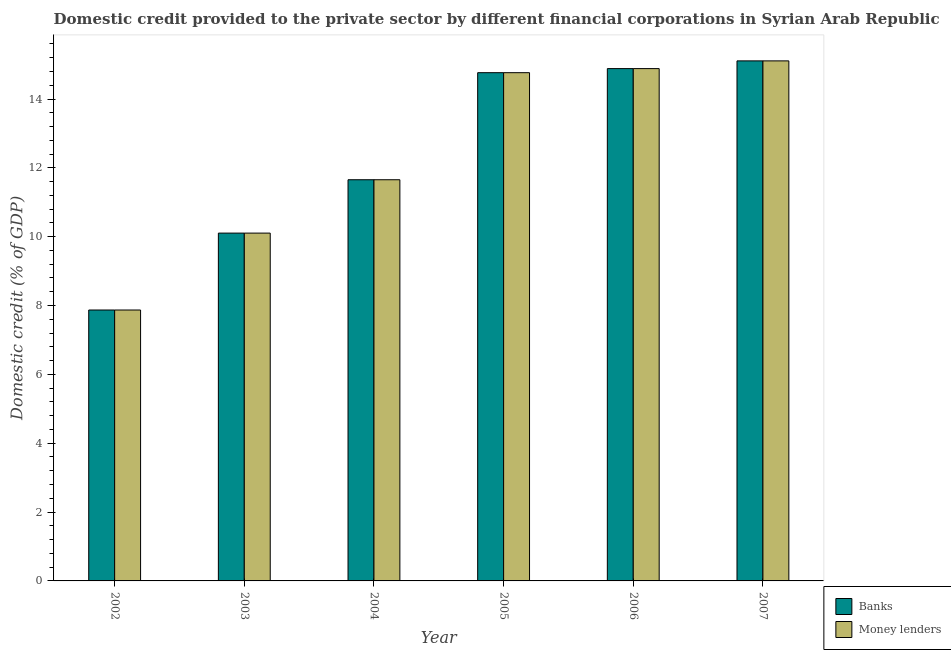Are the number of bars on each tick of the X-axis equal?
Offer a terse response. Yes. What is the label of the 6th group of bars from the left?
Provide a short and direct response. 2007. In how many cases, is the number of bars for a given year not equal to the number of legend labels?
Provide a short and direct response. 0. What is the domestic credit provided by money lenders in 2005?
Ensure brevity in your answer.  14.76. Across all years, what is the maximum domestic credit provided by money lenders?
Your response must be concise. 15.11. Across all years, what is the minimum domestic credit provided by banks?
Your answer should be compact. 7.87. In which year was the domestic credit provided by banks maximum?
Make the answer very short. 2007. What is the total domestic credit provided by money lenders in the graph?
Your answer should be very brief. 74.38. What is the difference between the domestic credit provided by money lenders in 2003 and that in 2006?
Your answer should be compact. -4.78. What is the difference between the domestic credit provided by money lenders in 2007 and the domestic credit provided by banks in 2004?
Give a very brief answer. 3.45. What is the average domestic credit provided by money lenders per year?
Provide a short and direct response. 12.4. In how many years, is the domestic credit provided by banks greater than 8.4 %?
Provide a short and direct response. 5. What is the ratio of the domestic credit provided by banks in 2003 to that in 2007?
Make the answer very short. 0.67. Is the domestic credit provided by money lenders in 2002 less than that in 2003?
Provide a short and direct response. Yes. What is the difference between the highest and the second highest domestic credit provided by banks?
Ensure brevity in your answer.  0.22. What is the difference between the highest and the lowest domestic credit provided by money lenders?
Keep it short and to the point. 7.24. In how many years, is the domestic credit provided by banks greater than the average domestic credit provided by banks taken over all years?
Your response must be concise. 3. What does the 2nd bar from the left in 2003 represents?
Keep it short and to the point. Money lenders. What does the 1st bar from the right in 2006 represents?
Your response must be concise. Money lenders. How many years are there in the graph?
Make the answer very short. 6. Are the values on the major ticks of Y-axis written in scientific E-notation?
Keep it short and to the point. No. Does the graph contain grids?
Ensure brevity in your answer.  No. How many legend labels are there?
Provide a succinct answer. 2. How are the legend labels stacked?
Your answer should be very brief. Vertical. What is the title of the graph?
Offer a terse response. Domestic credit provided to the private sector by different financial corporations in Syrian Arab Republic. Does "Canada" appear as one of the legend labels in the graph?
Give a very brief answer. No. What is the label or title of the Y-axis?
Provide a short and direct response. Domestic credit (% of GDP). What is the Domestic credit (% of GDP) of Banks in 2002?
Your answer should be very brief. 7.87. What is the Domestic credit (% of GDP) of Money lenders in 2002?
Provide a short and direct response. 7.87. What is the Domestic credit (% of GDP) of Banks in 2003?
Offer a very short reply. 10.1. What is the Domestic credit (% of GDP) in Money lenders in 2003?
Offer a terse response. 10.1. What is the Domestic credit (% of GDP) of Banks in 2004?
Provide a succinct answer. 11.65. What is the Domestic credit (% of GDP) in Money lenders in 2004?
Provide a succinct answer. 11.65. What is the Domestic credit (% of GDP) in Banks in 2005?
Your answer should be compact. 14.76. What is the Domestic credit (% of GDP) in Money lenders in 2005?
Make the answer very short. 14.76. What is the Domestic credit (% of GDP) of Banks in 2006?
Provide a succinct answer. 14.88. What is the Domestic credit (% of GDP) in Money lenders in 2006?
Offer a very short reply. 14.88. What is the Domestic credit (% of GDP) of Banks in 2007?
Your response must be concise. 15.11. What is the Domestic credit (% of GDP) of Money lenders in 2007?
Provide a short and direct response. 15.11. Across all years, what is the maximum Domestic credit (% of GDP) in Banks?
Provide a short and direct response. 15.11. Across all years, what is the maximum Domestic credit (% of GDP) of Money lenders?
Offer a very short reply. 15.11. Across all years, what is the minimum Domestic credit (% of GDP) in Banks?
Provide a short and direct response. 7.87. Across all years, what is the minimum Domestic credit (% of GDP) of Money lenders?
Make the answer very short. 7.87. What is the total Domestic credit (% of GDP) of Banks in the graph?
Your answer should be very brief. 74.38. What is the total Domestic credit (% of GDP) in Money lenders in the graph?
Ensure brevity in your answer.  74.38. What is the difference between the Domestic credit (% of GDP) of Banks in 2002 and that in 2003?
Ensure brevity in your answer.  -2.23. What is the difference between the Domestic credit (% of GDP) in Money lenders in 2002 and that in 2003?
Make the answer very short. -2.23. What is the difference between the Domestic credit (% of GDP) of Banks in 2002 and that in 2004?
Offer a terse response. -3.78. What is the difference between the Domestic credit (% of GDP) of Money lenders in 2002 and that in 2004?
Offer a very short reply. -3.78. What is the difference between the Domestic credit (% of GDP) in Banks in 2002 and that in 2005?
Make the answer very short. -6.89. What is the difference between the Domestic credit (% of GDP) of Money lenders in 2002 and that in 2005?
Your answer should be compact. -6.89. What is the difference between the Domestic credit (% of GDP) in Banks in 2002 and that in 2006?
Offer a terse response. -7.01. What is the difference between the Domestic credit (% of GDP) in Money lenders in 2002 and that in 2006?
Offer a very short reply. -7.01. What is the difference between the Domestic credit (% of GDP) in Banks in 2002 and that in 2007?
Provide a short and direct response. -7.24. What is the difference between the Domestic credit (% of GDP) of Money lenders in 2002 and that in 2007?
Ensure brevity in your answer.  -7.24. What is the difference between the Domestic credit (% of GDP) in Banks in 2003 and that in 2004?
Offer a terse response. -1.55. What is the difference between the Domestic credit (% of GDP) in Money lenders in 2003 and that in 2004?
Keep it short and to the point. -1.55. What is the difference between the Domestic credit (% of GDP) of Banks in 2003 and that in 2005?
Your answer should be compact. -4.66. What is the difference between the Domestic credit (% of GDP) of Money lenders in 2003 and that in 2005?
Give a very brief answer. -4.66. What is the difference between the Domestic credit (% of GDP) in Banks in 2003 and that in 2006?
Provide a succinct answer. -4.78. What is the difference between the Domestic credit (% of GDP) in Money lenders in 2003 and that in 2006?
Provide a short and direct response. -4.78. What is the difference between the Domestic credit (% of GDP) in Banks in 2003 and that in 2007?
Make the answer very short. -5. What is the difference between the Domestic credit (% of GDP) in Money lenders in 2003 and that in 2007?
Provide a short and direct response. -5. What is the difference between the Domestic credit (% of GDP) in Banks in 2004 and that in 2005?
Provide a short and direct response. -3.11. What is the difference between the Domestic credit (% of GDP) of Money lenders in 2004 and that in 2005?
Offer a very short reply. -3.11. What is the difference between the Domestic credit (% of GDP) in Banks in 2004 and that in 2006?
Offer a very short reply. -3.23. What is the difference between the Domestic credit (% of GDP) in Money lenders in 2004 and that in 2006?
Your answer should be very brief. -3.23. What is the difference between the Domestic credit (% of GDP) of Banks in 2004 and that in 2007?
Ensure brevity in your answer.  -3.45. What is the difference between the Domestic credit (% of GDP) of Money lenders in 2004 and that in 2007?
Your response must be concise. -3.45. What is the difference between the Domestic credit (% of GDP) of Banks in 2005 and that in 2006?
Make the answer very short. -0.12. What is the difference between the Domestic credit (% of GDP) in Money lenders in 2005 and that in 2006?
Your answer should be compact. -0.12. What is the difference between the Domestic credit (% of GDP) of Banks in 2005 and that in 2007?
Your answer should be very brief. -0.34. What is the difference between the Domestic credit (% of GDP) in Money lenders in 2005 and that in 2007?
Offer a very short reply. -0.34. What is the difference between the Domestic credit (% of GDP) in Banks in 2006 and that in 2007?
Offer a terse response. -0.22. What is the difference between the Domestic credit (% of GDP) in Money lenders in 2006 and that in 2007?
Ensure brevity in your answer.  -0.22. What is the difference between the Domestic credit (% of GDP) in Banks in 2002 and the Domestic credit (% of GDP) in Money lenders in 2003?
Your answer should be compact. -2.23. What is the difference between the Domestic credit (% of GDP) in Banks in 2002 and the Domestic credit (% of GDP) in Money lenders in 2004?
Offer a very short reply. -3.78. What is the difference between the Domestic credit (% of GDP) in Banks in 2002 and the Domestic credit (% of GDP) in Money lenders in 2005?
Your answer should be very brief. -6.89. What is the difference between the Domestic credit (% of GDP) of Banks in 2002 and the Domestic credit (% of GDP) of Money lenders in 2006?
Provide a short and direct response. -7.01. What is the difference between the Domestic credit (% of GDP) of Banks in 2002 and the Domestic credit (% of GDP) of Money lenders in 2007?
Your answer should be very brief. -7.24. What is the difference between the Domestic credit (% of GDP) in Banks in 2003 and the Domestic credit (% of GDP) in Money lenders in 2004?
Your answer should be very brief. -1.55. What is the difference between the Domestic credit (% of GDP) in Banks in 2003 and the Domestic credit (% of GDP) in Money lenders in 2005?
Make the answer very short. -4.66. What is the difference between the Domestic credit (% of GDP) of Banks in 2003 and the Domestic credit (% of GDP) of Money lenders in 2006?
Offer a very short reply. -4.78. What is the difference between the Domestic credit (% of GDP) of Banks in 2003 and the Domestic credit (% of GDP) of Money lenders in 2007?
Offer a very short reply. -5. What is the difference between the Domestic credit (% of GDP) in Banks in 2004 and the Domestic credit (% of GDP) in Money lenders in 2005?
Offer a very short reply. -3.11. What is the difference between the Domestic credit (% of GDP) of Banks in 2004 and the Domestic credit (% of GDP) of Money lenders in 2006?
Ensure brevity in your answer.  -3.23. What is the difference between the Domestic credit (% of GDP) of Banks in 2004 and the Domestic credit (% of GDP) of Money lenders in 2007?
Your response must be concise. -3.45. What is the difference between the Domestic credit (% of GDP) in Banks in 2005 and the Domestic credit (% of GDP) in Money lenders in 2006?
Provide a short and direct response. -0.12. What is the difference between the Domestic credit (% of GDP) in Banks in 2005 and the Domestic credit (% of GDP) in Money lenders in 2007?
Provide a succinct answer. -0.34. What is the difference between the Domestic credit (% of GDP) in Banks in 2006 and the Domestic credit (% of GDP) in Money lenders in 2007?
Ensure brevity in your answer.  -0.22. What is the average Domestic credit (% of GDP) of Banks per year?
Make the answer very short. 12.4. What is the average Domestic credit (% of GDP) in Money lenders per year?
Offer a very short reply. 12.4. In the year 2005, what is the difference between the Domestic credit (% of GDP) in Banks and Domestic credit (% of GDP) in Money lenders?
Your answer should be very brief. 0. In the year 2007, what is the difference between the Domestic credit (% of GDP) of Banks and Domestic credit (% of GDP) of Money lenders?
Provide a short and direct response. 0. What is the ratio of the Domestic credit (% of GDP) of Banks in 2002 to that in 2003?
Keep it short and to the point. 0.78. What is the ratio of the Domestic credit (% of GDP) in Money lenders in 2002 to that in 2003?
Your answer should be very brief. 0.78. What is the ratio of the Domestic credit (% of GDP) of Banks in 2002 to that in 2004?
Provide a succinct answer. 0.68. What is the ratio of the Domestic credit (% of GDP) of Money lenders in 2002 to that in 2004?
Your response must be concise. 0.68. What is the ratio of the Domestic credit (% of GDP) of Banks in 2002 to that in 2005?
Provide a short and direct response. 0.53. What is the ratio of the Domestic credit (% of GDP) of Money lenders in 2002 to that in 2005?
Keep it short and to the point. 0.53. What is the ratio of the Domestic credit (% of GDP) of Banks in 2002 to that in 2006?
Keep it short and to the point. 0.53. What is the ratio of the Domestic credit (% of GDP) in Money lenders in 2002 to that in 2006?
Give a very brief answer. 0.53. What is the ratio of the Domestic credit (% of GDP) of Banks in 2002 to that in 2007?
Provide a succinct answer. 0.52. What is the ratio of the Domestic credit (% of GDP) of Money lenders in 2002 to that in 2007?
Your response must be concise. 0.52. What is the ratio of the Domestic credit (% of GDP) in Banks in 2003 to that in 2004?
Keep it short and to the point. 0.87. What is the ratio of the Domestic credit (% of GDP) of Money lenders in 2003 to that in 2004?
Offer a terse response. 0.87. What is the ratio of the Domestic credit (% of GDP) in Banks in 2003 to that in 2005?
Keep it short and to the point. 0.68. What is the ratio of the Domestic credit (% of GDP) of Money lenders in 2003 to that in 2005?
Offer a very short reply. 0.68. What is the ratio of the Domestic credit (% of GDP) in Banks in 2003 to that in 2006?
Provide a short and direct response. 0.68. What is the ratio of the Domestic credit (% of GDP) in Money lenders in 2003 to that in 2006?
Keep it short and to the point. 0.68. What is the ratio of the Domestic credit (% of GDP) of Banks in 2003 to that in 2007?
Provide a succinct answer. 0.67. What is the ratio of the Domestic credit (% of GDP) of Money lenders in 2003 to that in 2007?
Keep it short and to the point. 0.67. What is the ratio of the Domestic credit (% of GDP) in Banks in 2004 to that in 2005?
Your response must be concise. 0.79. What is the ratio of the Domestic credit (% of GDP) in Money lenders in 2004 to that in 2005?
Keep it short and to the point. 0.79. What is the ratio of the Domestic credit (% of GDP) in Banks in 2004 to that in 2006?
Your response must be concise. 0.78. What is the ratio of the Domestic credit (% of GDP) of Money lenders in 2004 to that in 2006?
Provide a succinct answer. 0.78. What is the ratio of the Domestic credit (% of GDP) of Banks in 2004 to that in 2007?
Offer a very short reply. 0.77. What is the ratio of the Domestic credit (% of GDP) of Money lenders in 2004 to that in 2007?
Keep it short and to the point. 0.77. What is the ratio of the Domestic credit (% of GDP) of Banks in 2005 to that in 2006?
Offer a very short reply. 0.99. What is the ratio of the Domestic credit (% of GDP) in Money lenders in 2005 to that in 2006?
Your answer should be very brief. 0.99. What is the ratio of the Domestic credit (% of GDP) of Banks in 2005 to that in 2007?
Make the answer very short. 0.98. What is the ratio of the Domestic credit (% of GDP) of Money lenders in 2005 to that in 2007?
Ensure brevity in your answer.  0.98. What is the ratio of the Domestic credit (% of GDP) of Banks in 2006 to that in 2007?
Give a very brief answer. 0.99. What is the ratio of the Domestic credit (% of GDP) in Money lenders in 2006 to that in 2007?
Offer a very short reply. 0.99. What is the difference between the highest and the second highest Domestic credit (% of GDP) in Banks?
Offer a very short reply. 0.22. What is the difference between the highest and the second highest Domestic credit (% of GDP) of Money lenders?
Ensure brevity in your answer.  0.22. What is the difference between the highest and the lowest Domestic credit (% of GDP) in Banks?
Provide a succinct answer. 7.24. What is the difference between the highest and the lowest Domestic credit (% of GDP) in Money lenders?
Make the answer very short. 7.24. 